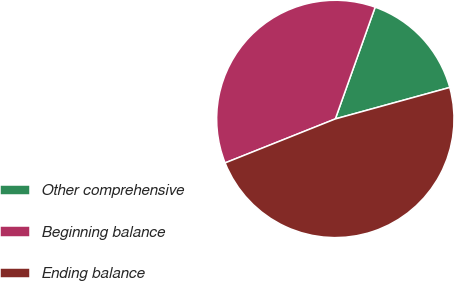Convert chart. <chart><loc_0><loc_0><loc_500><loc_500><pie_chart><fcel>Other comprehensive<fcel>Beginning balance<fcel>Ending balance<nl><fcel>15.28%<fcel>36.49%<fcel>48.23%<nl></chart> 